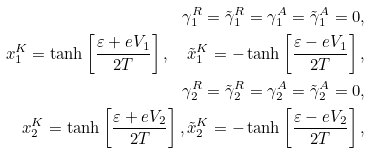Convert formula to latex. <formula><loc_0><loc_0><loc_500><loc_500>\gamma _ { 1 } ^ { R } = \tilde { \gamma } _ { 1 } ^ { R } = \gamma _ { 1 } ^ { A } = \tilde { \gamma } _ { 1 } ^ { A } = 0 , \\ x _ { 1 } ^ { K } = \tanh \left [ \frac { \varepsilon + e V _ { 1 } } { 2 T } \right ] , \quad \tilde { x } _ { 1 } ^ { K } = - \tanh \left [ \frac { \varepsilon - e V _ { 1 } } { 2 T } \right ] , \\ \gamma _ { 2 } ^ { R } = \tilde { \gamma } _ { 2 } ^ { R } = \gamma _ { 2 } ^ { A } = \tilde { \gamma } _ { 2 } ^ { A } = 0 , \\ x _ { 2 } ^ { K } = \tanh \left [ \frac { \varepsilon + e V _ { 2 } } { 2 T } \right ] , \tilde { x } _ { 2 } ^ { K } = - \tanh \left [ \frac { \varepsilon - e V _ { 2 } } { 2 T } \right ] ,</formula> 